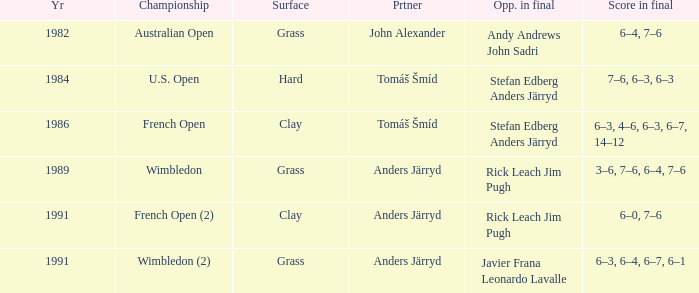What was the final score in 1986? 6–3, 4–6, 6–3, 6–7, 14–12. 